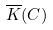<formula> <loc_0><loc_0><loc_500><loc_500>\overline { K } ( C )</formula> 